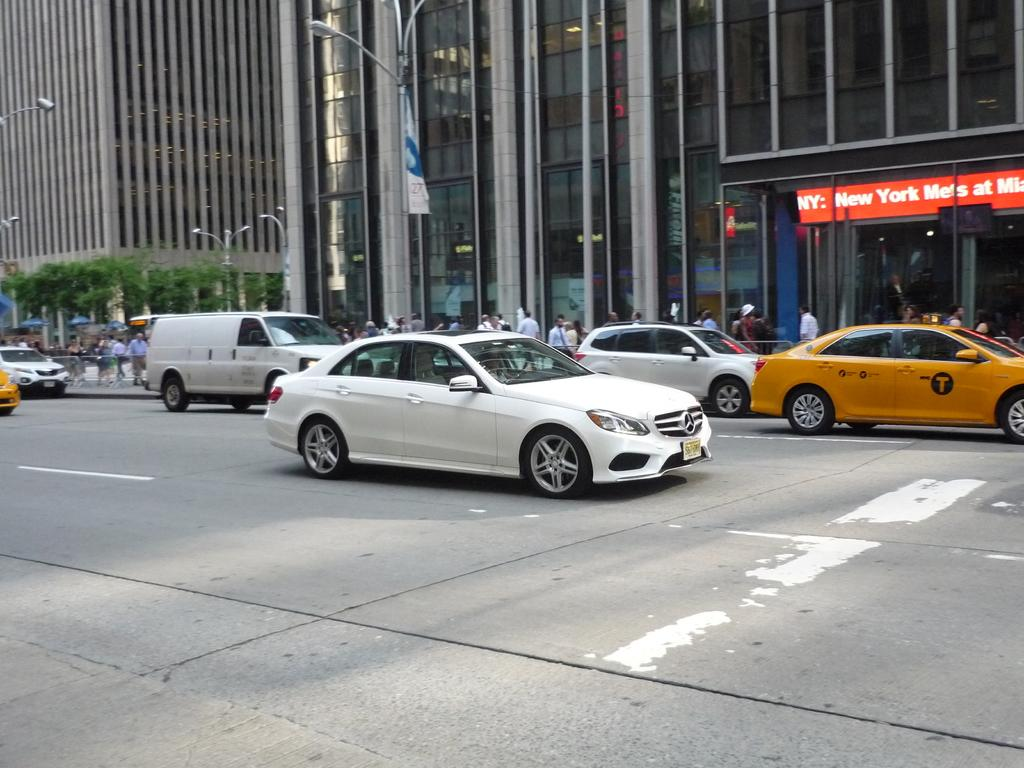<image>
Provide a brief description of the given image. a sign for New York that is next to the road 